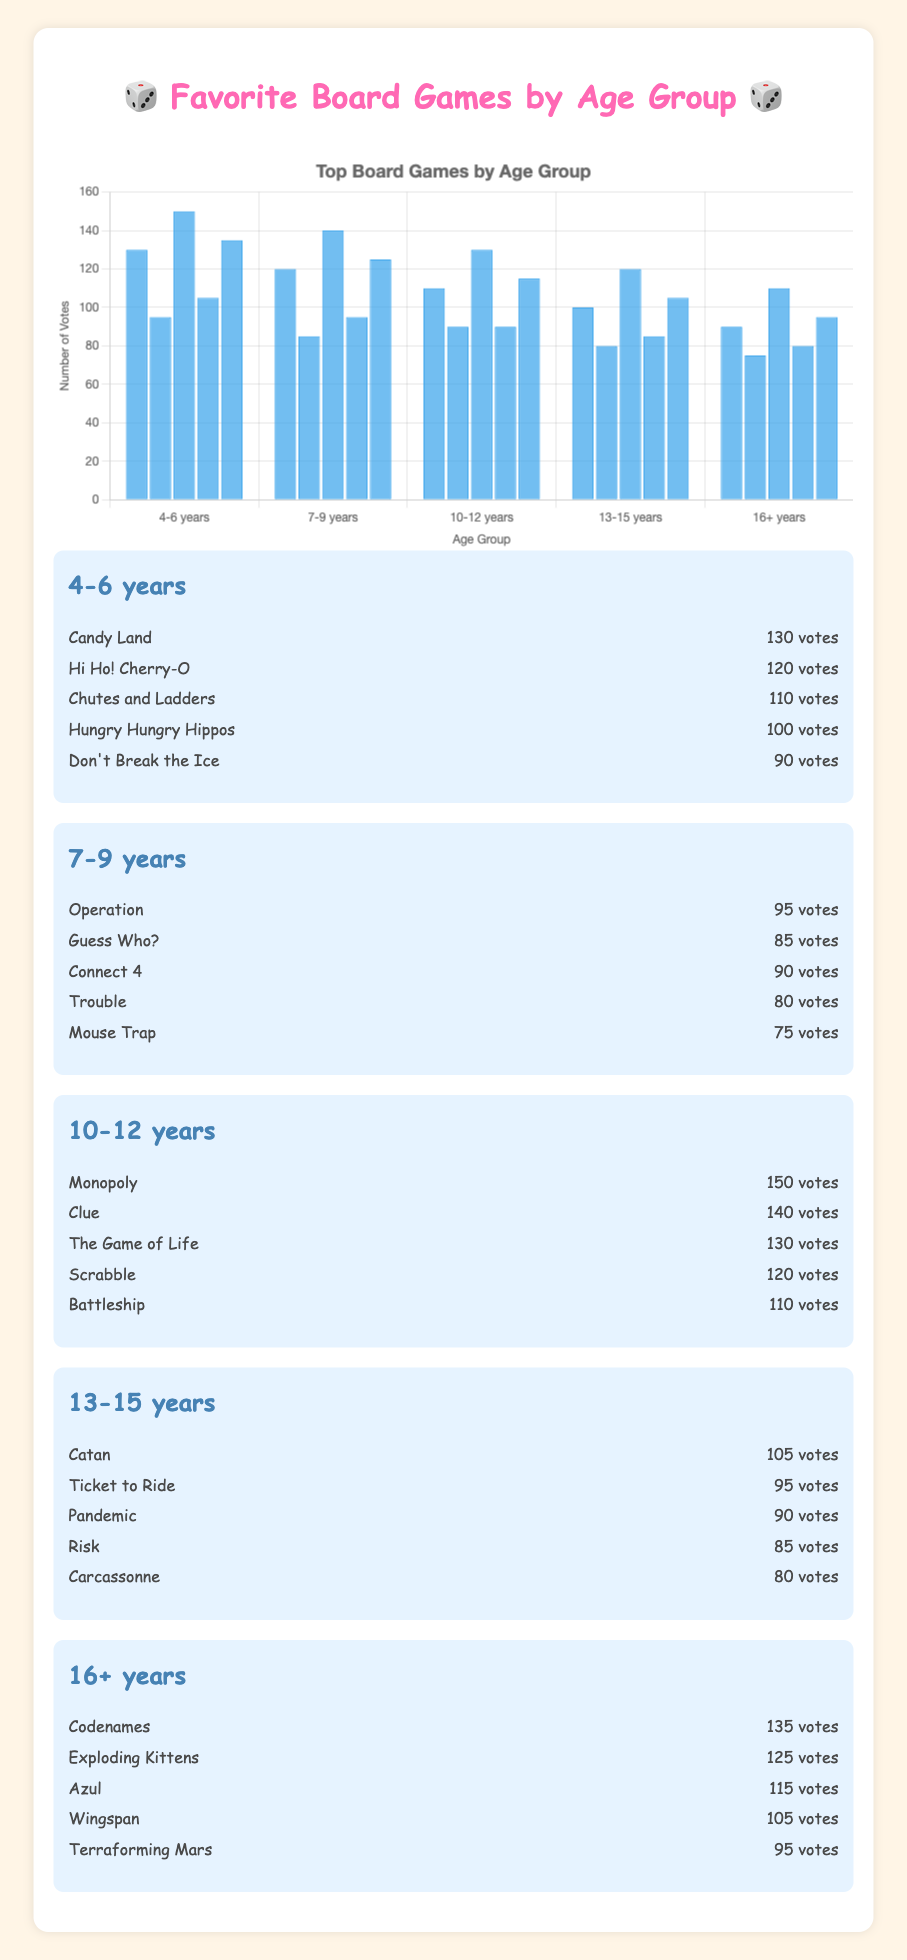What's the favorite board game for the 4-6 years age group? To find this, look at the bar with the highest height in the 4-6 years age group. The game with the highest votes for this age group is "Candy Land" with 130 votes.
Answer: Candy Land How many more votes does Codenames have compared to Wingspan in the 16+ years age group? Compare the heights of the bars for Codenames and Wingspan in the 16+ years age group. Codenames has 135 votes and Wingspan has 105 votes. The difference is 135 - 105.
Answer: 30 Which age group has the highest vote count for a single game? Look for the tallest bar across all age groups. The tallest bar is in the 10-12 years age group for the game "Monopoly" with 150 votes.
Answer: 10-12 years What is the total number of votes for the top 3 games in the 10-12 years age group? Add the votes of the top 3 games in the 10-12 years age group: Monopoly (150), Clue (140), and The Game of Life (130). The sum is 150 + 140 + 130.
Answer: 420 Which game received the fewest votes in the 7-9 years age group? Look for the shortest bar in the 7-9 years age group. The game with the fewest votes is "Mouse Trap" with 75 votes.
Answer: Mouse Trap Are there any age groups where all games have votes above 100? Check the heights of the bars for each game in each age group. The 4-6 years and 16+ years age groups have at least one game with votes below 100. The 7-9 years age group also includes games below 100. The 10-12 years age group has all votes above 100.
Answer: 10-12 years What's the total number of votes for games in the 13-15 years age group? Add up all the votes for the games in the 13-15 years age group: Catan (105), Ticket to Ride (95), Pandemic (90), Risk (85), Carcassonne (80). The sum is 105 + 95 + 90 + 85 + 80.
Answer: 455 Which two age groups have the closest total votes for their top games? First find the highest votes for each age group: 4-6 years (Candy Land: 130), 7-9 years (Operation: 95), 10-12 years (Monopoly: 150), 13-15 years (Catan: 105), 16+ years (Codenames: 135). Then find the differences: 135 vs 130 (5), 130 vs 95 (35), 150 vs 95 (55), etc. The closest two groups are 4-6 years (130) and 16+ years (135).
Answer: 4-6 years and 16+ years Which game among all age groups received the highest number of votes? Identify the highest bar in the entire chart. The game with the highest votes is "Monopoly" in the 10-12 years age group with 150 votes.
Answer: Monopoly 